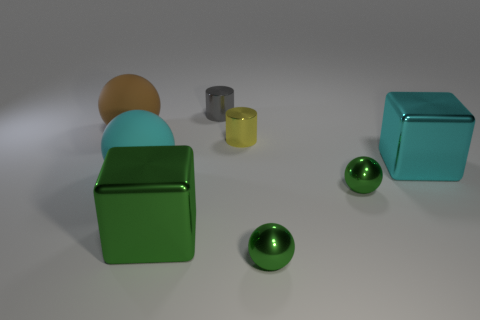Do the gray cylinder and the cyan object on the left side of the large green metallic cube have the same material?
Your response must be concise. No. There is a cube that is to the left of the gray cylinder; is its size the same as the cyan object that is to the left of the cyan shiny block?
Your response must be concise. Yes. There is a cyan rubber sphere; how many big brown rubber things are to the left of it?
Provide a succinct answer. 1. Are there any gray objects made of the same material as the yellow cylinder?
Your response must be concise. Yes. There is a brown ball that is the same size as the green cube; what is it made of?
Your response must be concise. Rubber. What size is the object that is both on the left side of the gray metallic object and behind the small yellow cylinder?
Offer a terse response. Large. What is the color of the ball that is both to the left of the yellow cylinder and to the right of the brown rubber sphere?
Offer a very short reply. Cyan. Is the number of brown objects that are right of the large green object less than the number of small yellow metal cylinders on the right side of the large brown rubber thing?
Provide a short and direct response. Yes. How many other tiny things have the same shape as the small yellow thing?
Ensure brevity in your answer.  1. The other block that is the same material as the large green cube is what size?
Your response must be concise. Large. 